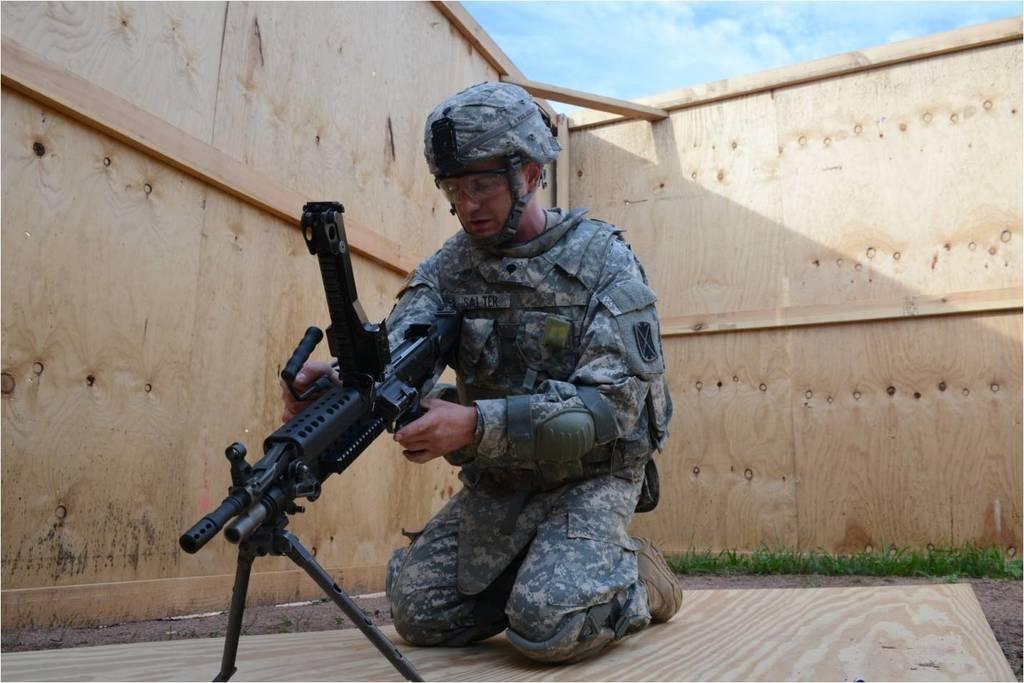Describe this image in one or two sentences. There is a man sitting on knees and holding gun and wore helmet and glasses. We can see gun with stand. On the background we can see grass and sky with clouds. 